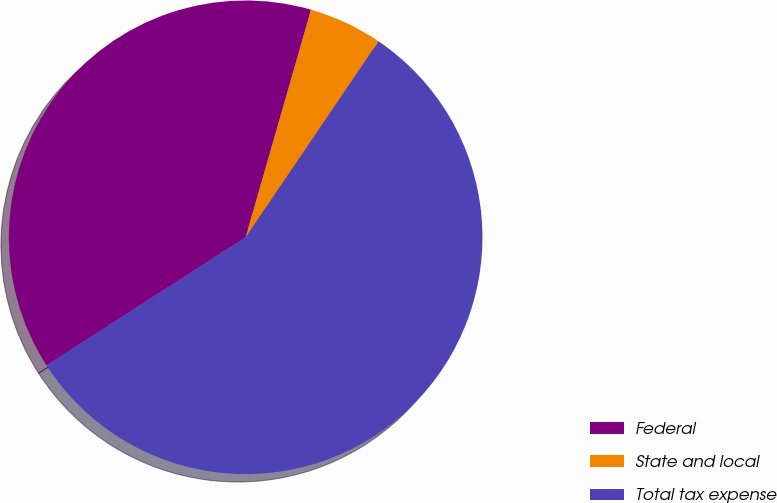Convert chart. <chart><loc_0><loc_0><loc_500><loc_500><pie_chart><fcel>Federal<fcel>State and local<fcel>Total tax expense<nl><fcel>38.55%<fcel>5.03%<fcel>56.42%<nl></chart> 